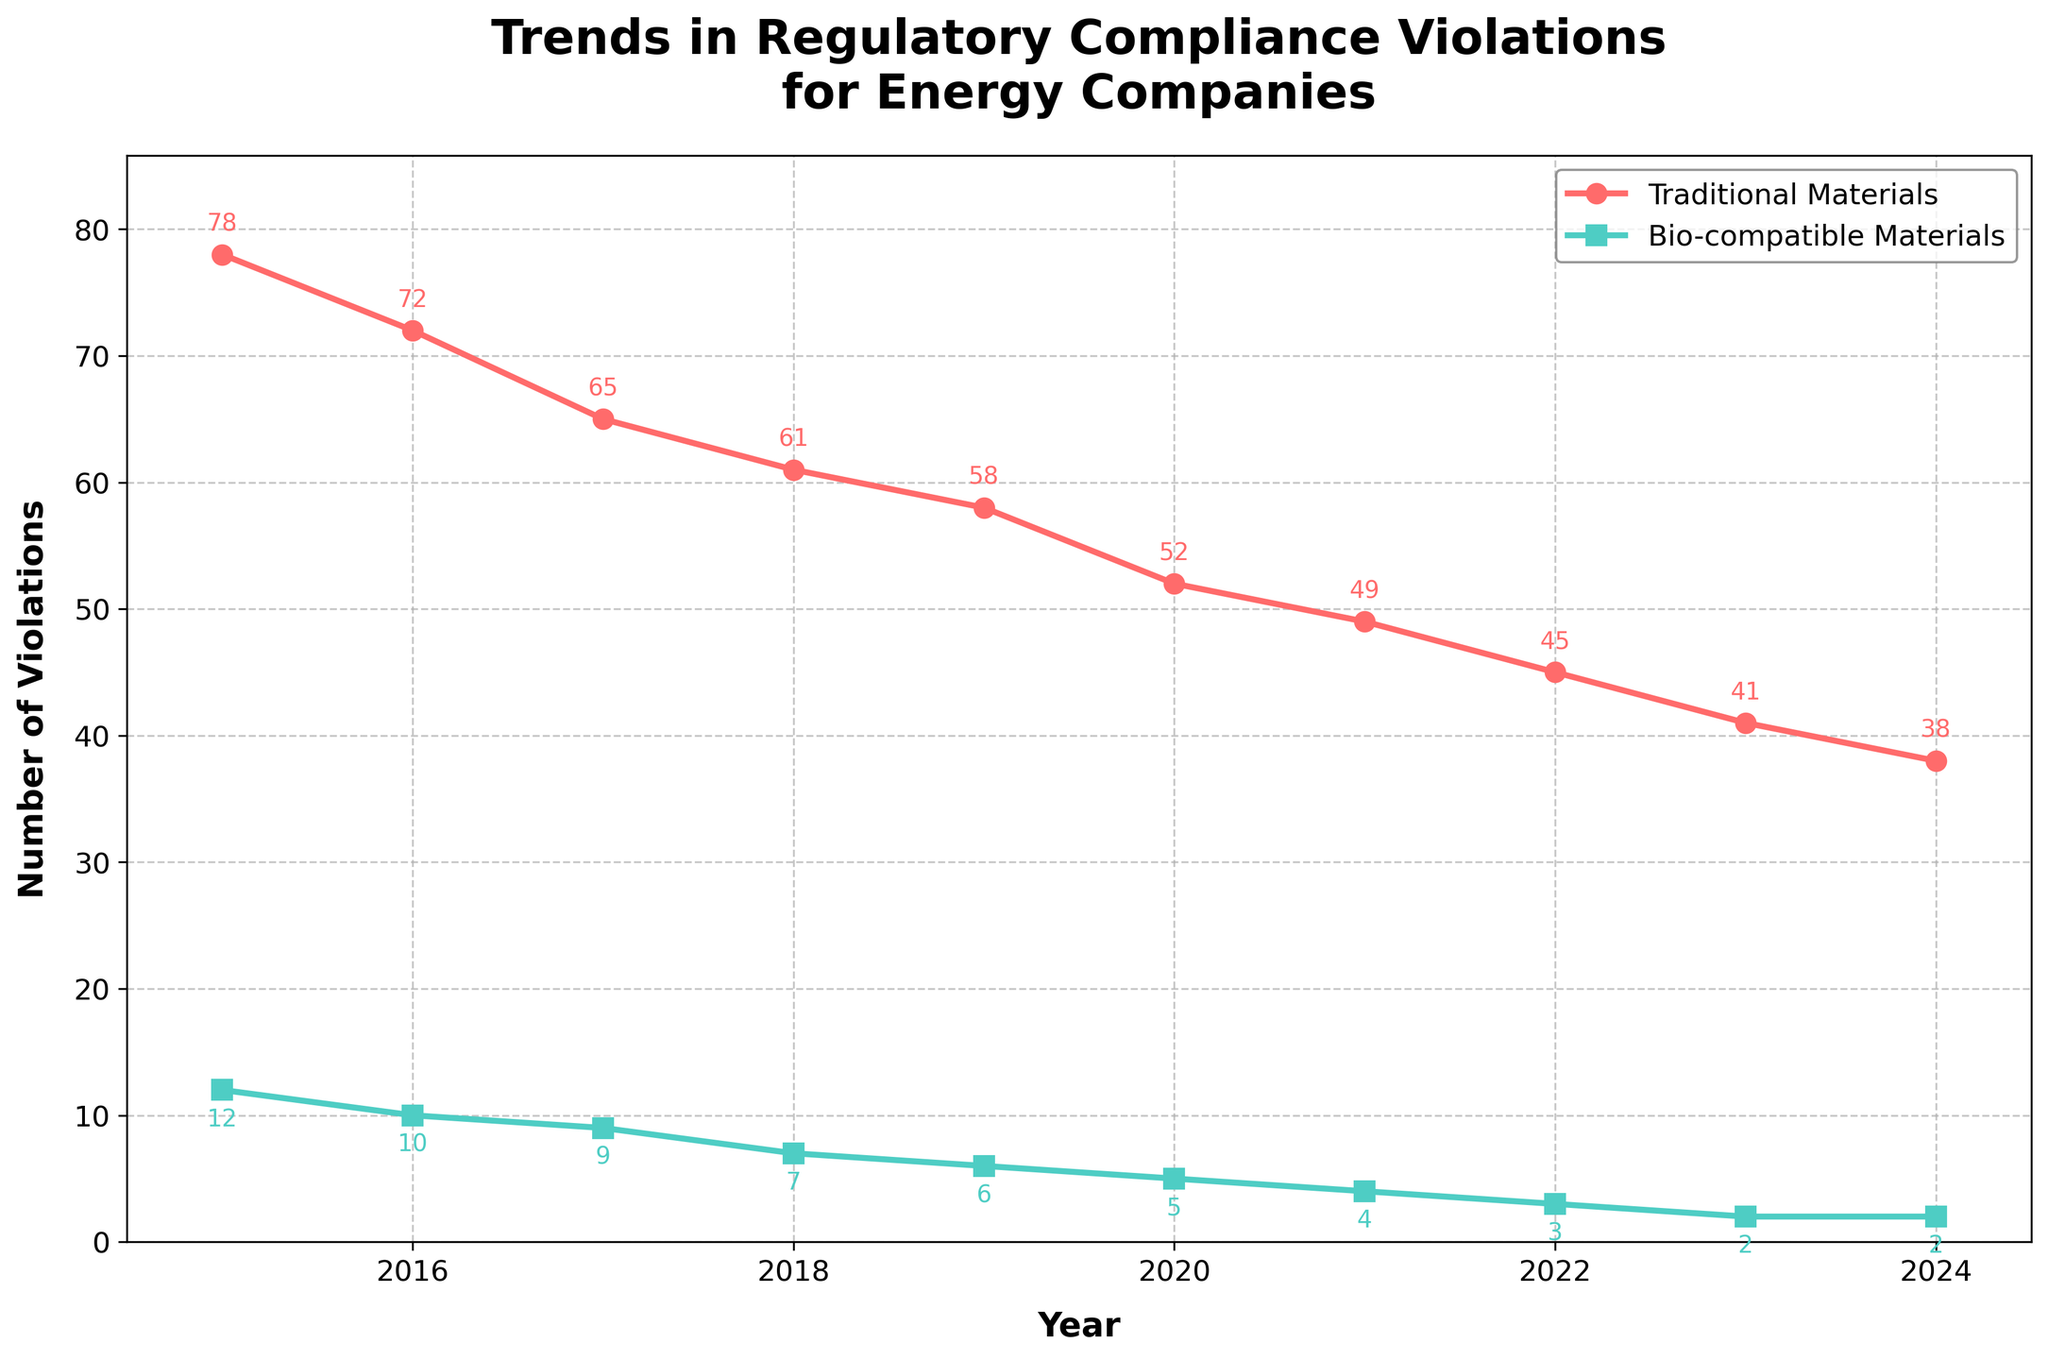Which type of materials sees fewer regulatory compliance violations over time? The figure shows the trend lines of violations for both types of materials. The green line represents bio-compatible materials and is consistently lower than the red line representing traditional materials.
Answer: Bio-compatible materials How many more violations did traditional materials have compared to bio-compatible materials in 2015? The figure shows that in 2015, traditional materials had 78 violations and bio-compatible materials had 12 violations. The difference is 78 - 12.
Answer: 66 In which year did traditional materials experience a significant drop in violations to under 50? Referring to the red line on the plot, the number of violations for traditional materials dipped below 50 in the year 2021.
Answer: 2021 What's the average number of violations for bio-compatible materials over the given years? To find the average, sum the number of violations for each year (12 + 10 + 9 + 7 + 6 + 5 + 4 + 3 + 2 + 2) and then divide by the number of years (10). The total is 60. The average is 60/10.
Answer: 6 Which year experienced the highest number of violations for both traditional and bio-compatible materials? The figure shows the highest point for each line. For traditional materials (red line), it's in 2015 with 78 violations, and for bio-compatible materials (green line), it's in 2015 with 12 violations.
Answer: 2015 How many years did bio-compatible materials have more than 5 violations? Observing the green line, bio-compatible materials had more than 5 violations from 2015 to 2019.
Answer: 5 years By how much did violations for traditional materials decrease from 2015 to 2024? The figure indicates that traditional materials had 78 violations in 2015 and 38 in 2024. The decrease is 78 - 38.
Answer: 40 What is the ratio of traditional materials violations to bio-compatible materials violations in 2023? In 2023, the chart shows that traditional materials had 41 violations and bio-compatible materials had 2. The ratio is 41 to 2 or 41:2.
Answer: 41:2 Do traditional materials ever experience less than 40 violations in the years shown? The lowest point of the red line representing traditional materials slightly drops below 40 in 2024.
Answer: Yes In which years do traditional and bio-compatible materials both show a decrease in the number of violations compared to the previous year? Observing the trend, both materials show a decrease every year, but specific years like 2017, 2020, 2022 are examples where both types had fewer violations than the previous year.
Answer: Every year 